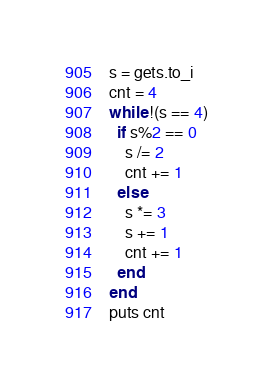Convert code to text. <code><loc_0><loc_0><loc_500><loc_500><_Ruby_>s = gets.to_i
cnt = 4
while !(s == 4)
  if s%2 == 0
    s /= 2
    cnt += 1
  else
    s *= 3
    s += 1
    cnt += 1
  end
end
puts cnt</code> 